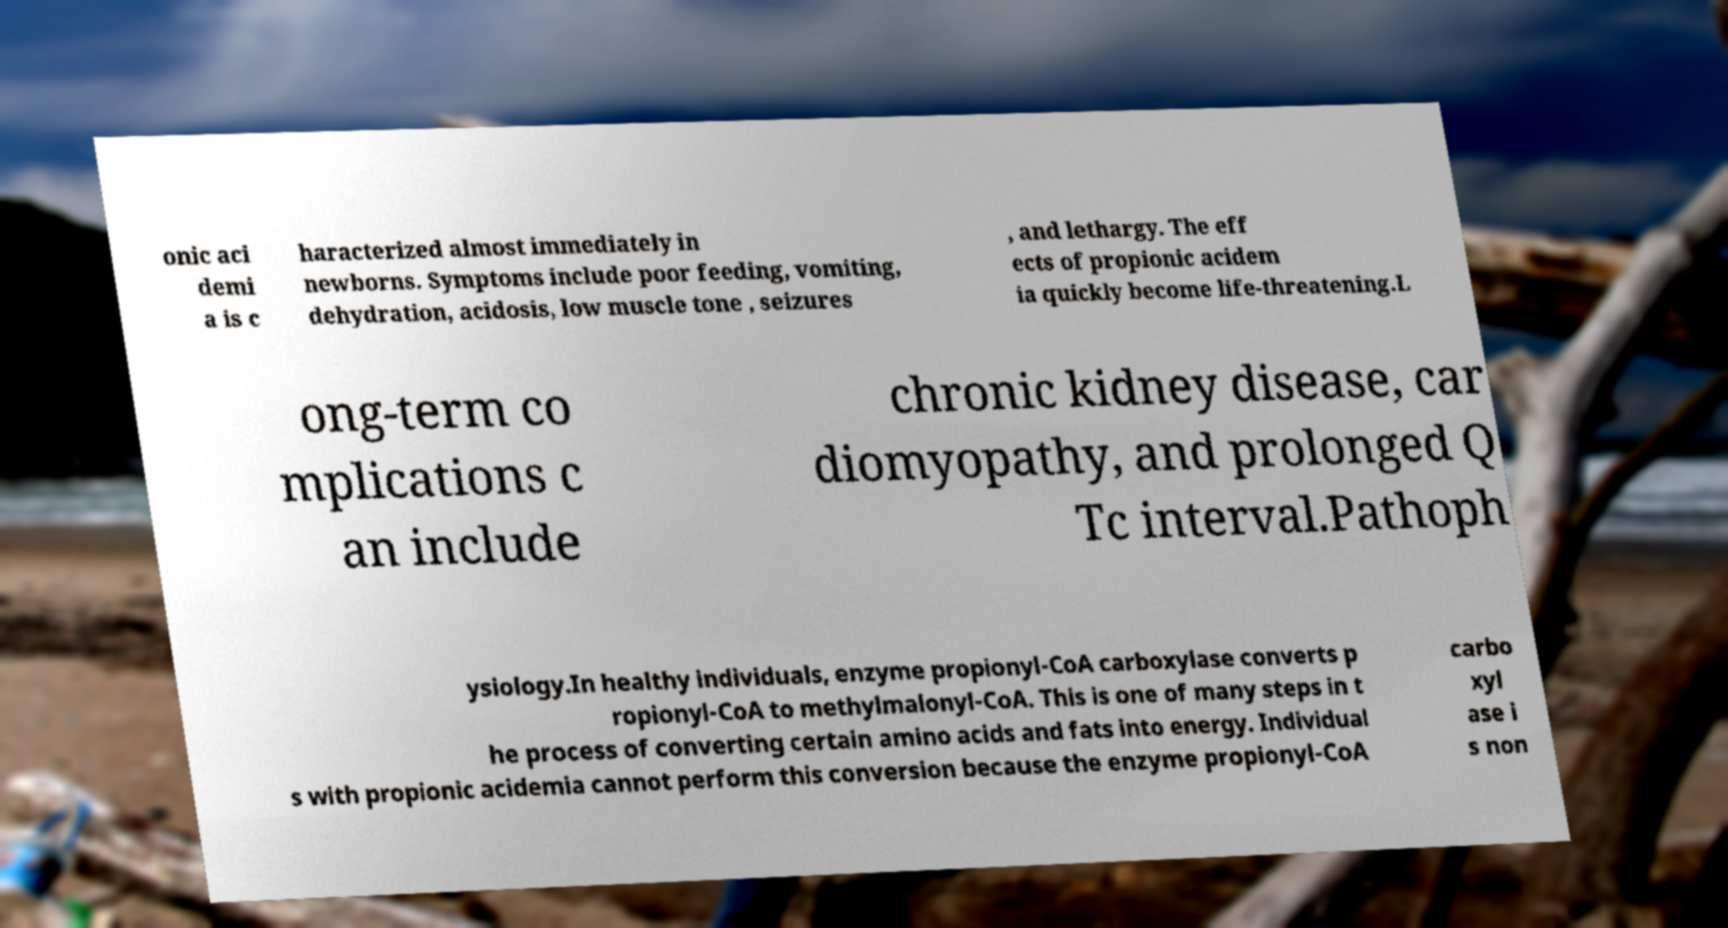I need the written content from this picture converted into text. Can you do that? onic aci demi a is c haracterized almost immediately in newborns. Symptoms include poor feeding, vomiting, dehydration, acidosis, low muscle tone , seizures , and lethargy. The eff ects of propionic acidem ia quickly become life-threatening.L ong-term co mplications c an include chronic kidney disease, car diomyopathy, and prolonged Q Tc interval.Pathoph ysiology.In healthy individuals, enzyme propionyl-CoA carboxylase converts p ropionyl-CoA to methylmalonyl-CoA. This is one of many steps in t he process of converting certain amino acids and fats into energy. Individual s with propionic acidemia cannot perform this conversion because the enzyme propionyl-CoA carbo xyl ase i s non 